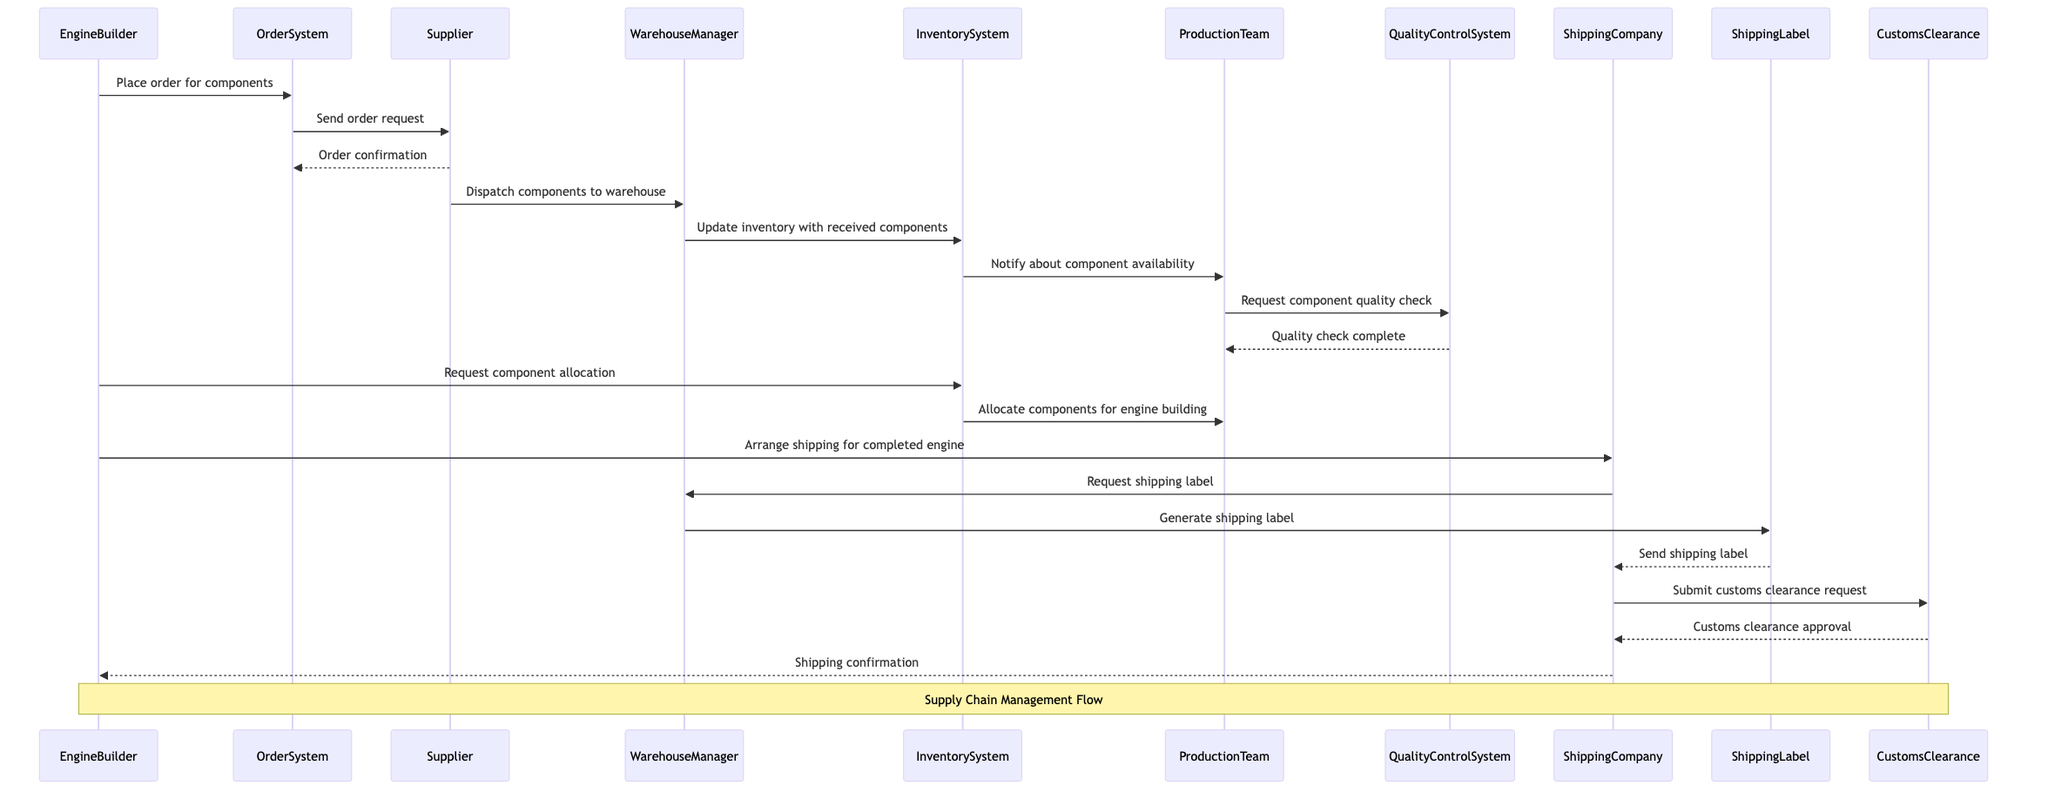What is the first action taken by the EngineBuilder? The EngineBuilder initiates the sequence by placing an order for components through the OrderSystem. This is the first message in the diagram.
Answer: Place order for components How many actors are involved in the supply chain management sequence? By counting the distinct participants listed in the diagram, there are five actors involved: EngineBuilder, Supplier, WarehouseManager, ProductionTeam, and ShippingCompany.
Answer: Five Which system is responsible for allocating components for engine building? The InventorySystem is the component responsible for informing the ProductionTeam to allocate the components needed for engine building, as shown after the request for allocation by the EngineBuilder.
Answer: InventorySystem What does the QualityControlSystem verify? The QualityControlSystem is tasked with conducting a quality check on the components requested by the ProductionTeam, which is shown in a message flow between the two entities.
Answer: Component quality check What is the last step in the supply chain management flow? The final step in the sequence is the ShippingCompany sending a shipping confirmation back to the EngineBuilder, indicating that the shipping process has been completed successfully.
Answer: Shipping confirmation Which participant does the Supplier send the order confirmation to? The Supplier sends the order confirmation back directly to the OrderSystem, completing the interaction for order placement.
Answer: OrderSystem What occurs after the WarehouseManager updates the inventory? After updating the inventory in the InventorySystem, a notification is sent to the ProductionTeam about the availability of the components, indicating the next step in the flow.
Answer: Notify about component availability How many messages are exchanged between the ShippingCompany and the WarehouseManager? There are two messages exchanged between the ShippingCompany and the WarehouseManager: one requesting a shipping label and one receiving the generated label.
Answer: Two 